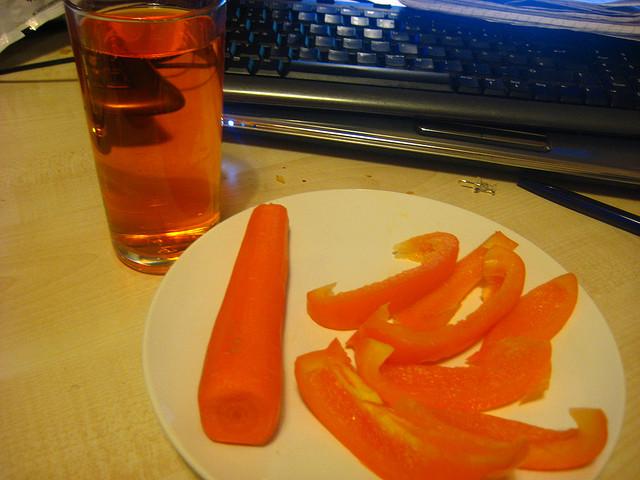Is the glass full?
Short answer required. Yes. Is this diner food?
Short answer required. No. Is that a keyboard  in the background?
Give a very brief answer. Yes. What is in the plate?
Write a very short answer. Carrot. 